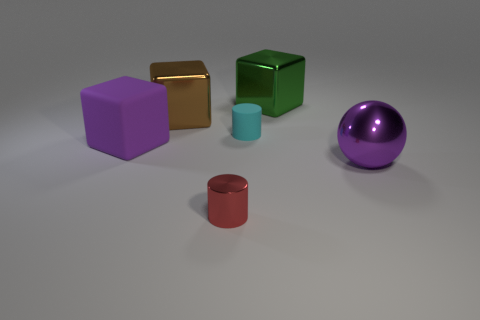Add 1 red balls. How many objects exist? 7 Subtract all cylinders. How many objects are left? 4 Subtract 1 purple balls. How many objects are left? 5 Subtract all cyan cylinders. Subtract all large metal blocks. How many objects are left? 3 Add 6 large shiny objects. How many large shiny objects are left? 9 Add 4 big cyan matte cubes. How many big cyan matte cubes exist? 4 